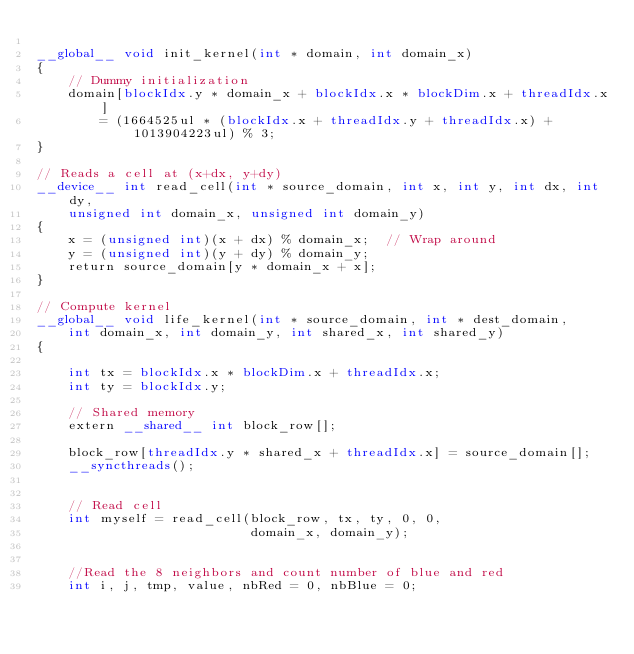Convert code to text. <code><loc_0><loc_0><loc_500><loc_500><_Cuda_>
__global__ void init_kernel(int * domain, int domain_x)
{
	// Dummy initialization
	domain[blockIdx.y * domain_x + blockIdx.x * blockDim.x + threadIdx.x]
		= (1664525ul * (blockIdx.x + threadIdx.y + threadIdx.x) + 1013904223ul) % 3;
}

// Reads a cell at (x+dx, y+dy)
__device__ int read_cell(int * source_domain, int x, int y, int dx, int dy,
    unsigned int domain_x, unsigned int domain_y)
{
    x = (unsigned int)(x + dx) % domain_x;	// Wrap around
    y = (unsigned int)(y + dy) % domain_y;
    return source_domain[y * domain_x + x];
}

// Compute kernel
__global__ void life_kernel(int * source_domain, int * dest_domain,
    int domain_x, int domain_y, int shared_x, int shared_y)
{

    int tx = blockIdx.x * blockDim.x + threadIdx.x;
    int ty = blockIdx.y;

    // Shared memory
    extern __shared__ int block_row[];

    block_row[threadIdx.y * shared_x + threadIdx.x] = source_domain[];
    __syncthreads();


    // Read cell
    int myself = read_cell(block_row, tx, ty, 0, 0,
	                       domain_x, domain_y);


    //Read the 8 neighbors and count number of blue and red
    int i, j, tmp, value, nbRed = 0, nbBlue = 0;</code> 